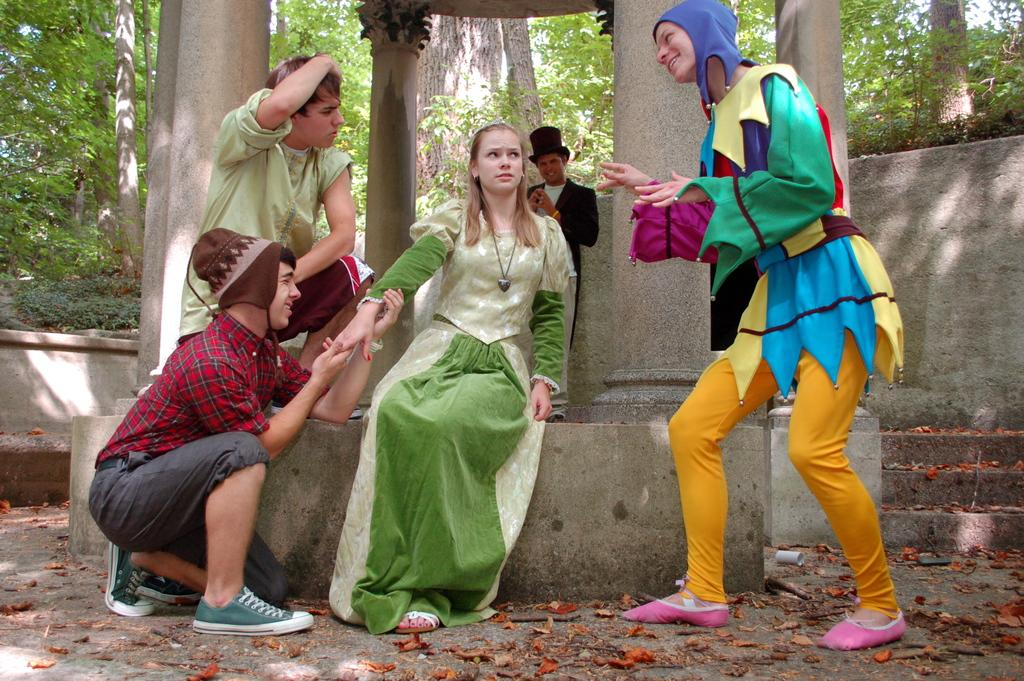What are the people in the image doing? The people in the image are sitting. Can you describe the person on the right side of the image? There is a person standing at the right side of the image. What architectural features can be seen in the image? There are pillars visible in the image. What type of vegetation is in the background of the image? There are green color trees in the background of the image. Can you tell me how many rabbits are hopping around in the image? There are no rabbits present in the image. What type of exchange is taking place between the people in the image? The image does not show any exchange taking place between the people. 